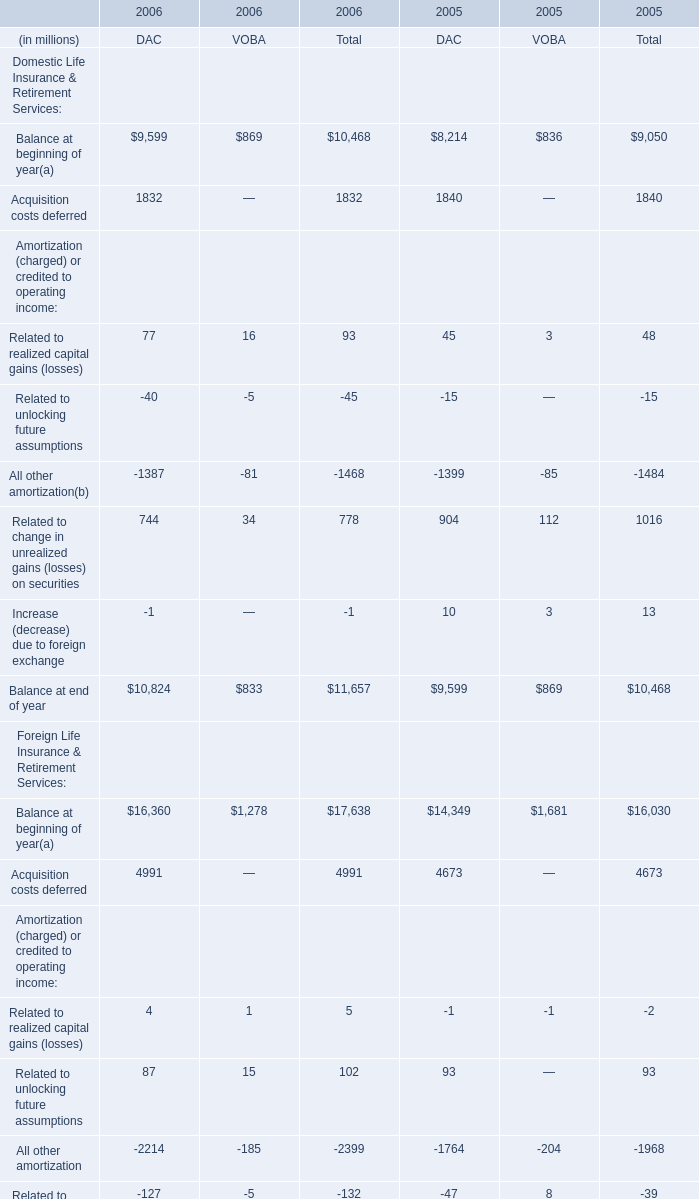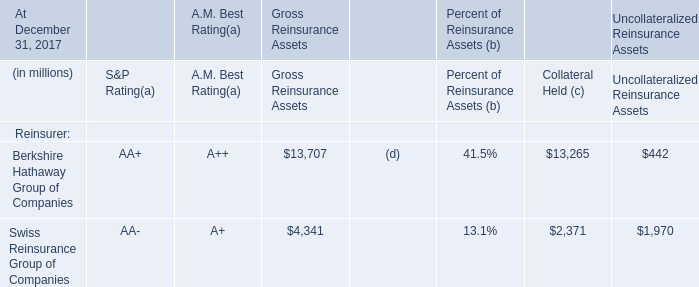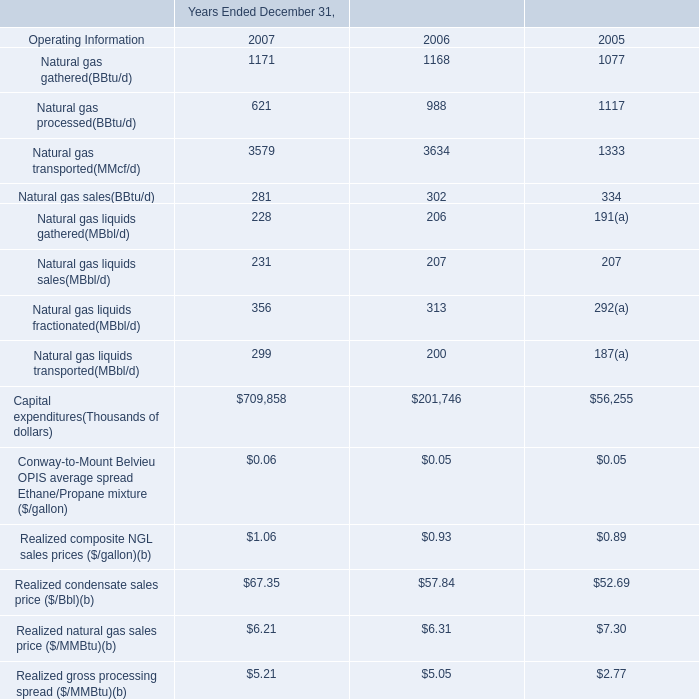What's the sum of Swiss Reinsurance Group of Companies of Gross Reinsurance Assets, and Balance at beginning of year of 2006 DAC ? 
Computations: (4341.0 + 9599.0)
Answer: 13940.0. 